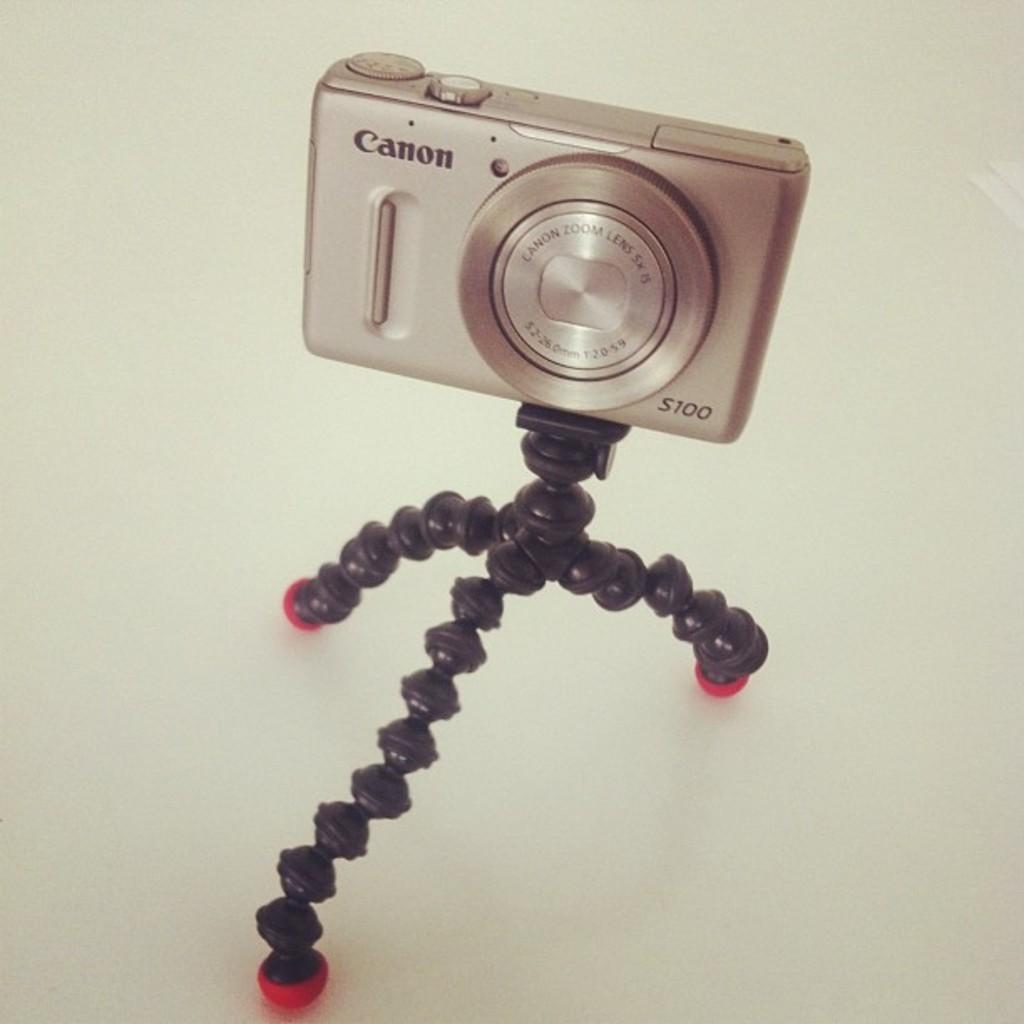What object is the main subject of the image? There is a camera in the image. How is the camera positioned in the image? The camera is on a stand. What color is the camera? The camera is black in color. Is there any text visible on the camera? Yes, there is text written on the camera. How many legs does the camera have in the image? The camera does not have legs; it is on a stand. Can you describe how the camera is twisting in the image? The camera is not twisting in the image; it is stationary on the stand. 